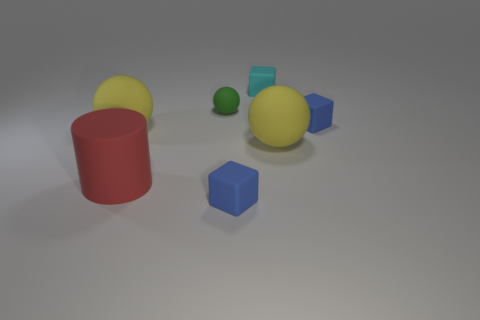Subtract all small blue rubber blocks. How many blocks are left? 1 Subtract all red cylinders. How many yellow spheres are left? 2 Subtract all green balls. How many balls are left? 2 Subtract 1 balls. How many balls are left? 2 Add 1 small green matte spheres. How many objects exist? 8 Subtract all blocks. How many objects are left? 4 Subtract all cyan balls. Subtract all yellow cubes. How many balls are left? 3 Add 7 red cylinders. How many red cylinders are left? 8 Add 5 small cyan objects. How many small cyan objects exist? 6 Subtract 0 red balls. How many objects are left? 7 